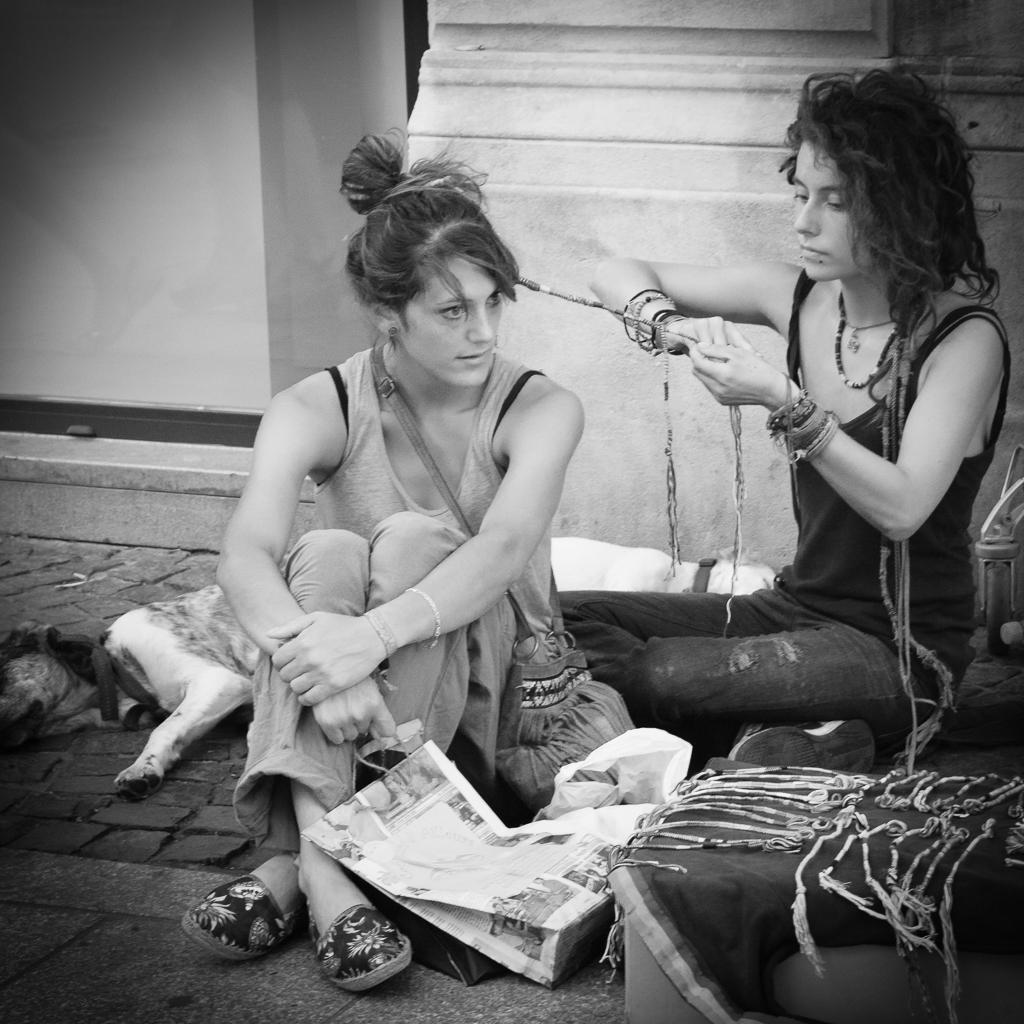Could you give a brief overview of what you see in this image? In this picture we can see two people sitting on the floor, here we can see a bag, dogs and some objects and we can see a wall in the background. 